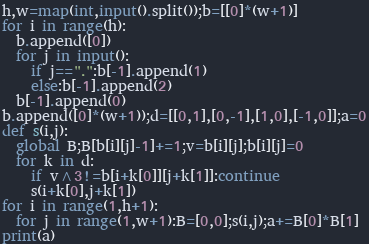Convert code to text. <code><loc_0><loc_0><loc_500><loc_500><_Python_>h,w=map(int,input().split());b=[[0]*(w+1)]
for i in range(h):
  b.append([0])
  for j in input():
    if j==".":b[-1].append(1)
    else:b[-1].append(2)
  b[-1].append(0)
b.append([0]*(w+1));d=[[0,1],[0,-1],[1,0],[-1,0]];a=0
def s(i,j):
  global B;B[b[i][j]-1]+=1;v=b[i][j];b[i][j]=0
  for k in d:
    if v^3!=b[i+k[0]][j+k[1]]:continue
    s(i+k[0],j+k[1])
for i in range(1,h+1):
  for j in range(1,w+1):B=[0,0];s(i,j);a+=B[0]*B[1]
print(a)</code> 